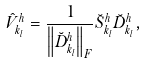Convert formula to latex. <formula><loc_0><loc_0><loc_500><loc_500>\hat { V } ^ { h } _ { k _ { l } } = \frac { 1 } { \left \| \breve { D } _ { k _ { l } } ^ { h } \right \| _ { F } } \breve { S } ^ { h } _ { k _ { l } } \breve { D } _ { k _ { l } } ^ { h } ,</formula> 